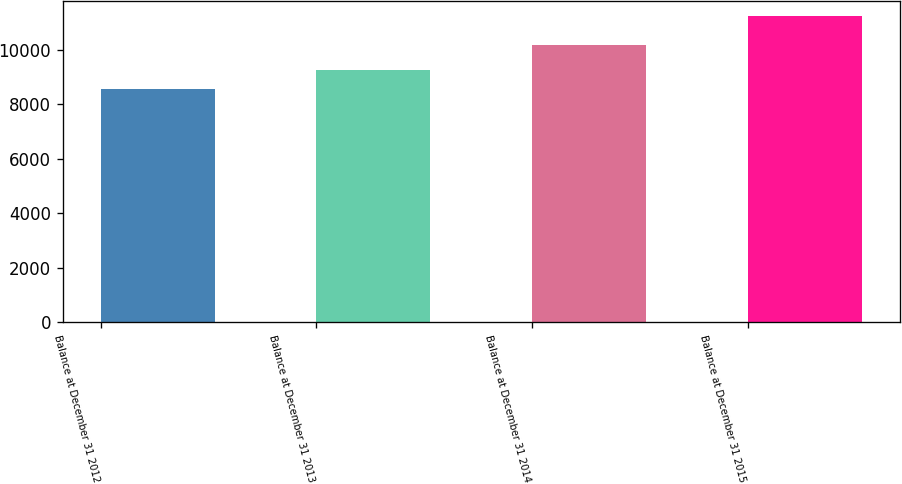Convert chart to OTSL. <chart><loc_0><loc_0><loc_500><loc_500><bar_chart><fcel>Balance at December 31 2012<fcel>Balance at December 31 2013<fcel>Balance at December 31 2014<fcel>Balance at December 31 2015<nl><fcel>8554<fcel>9253<fcel>10198<fcel>11253<nl></chart> 